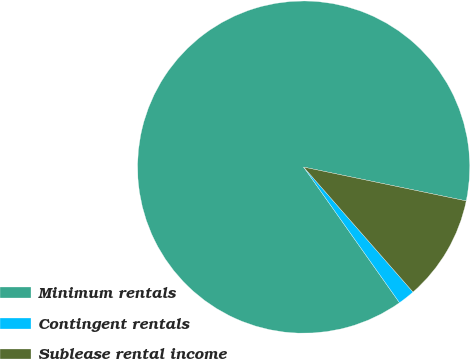<chart> <loc_0><loc_0><loc_500><loc_500><pie_chart><fcel>Minimum rentals<fcel>Contingent rentals<fcel>Sublease rental income<nl><fcel>88.05%<fcel>1.65%<fcel>10.29%<nl></chart> 